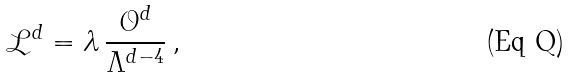Convert formula to latex. <formula><loc_0><loc_0><loc_500><loc_500>\mathcal { L } ^ { d } = \lambda \, \frac { \mathcal { O } ^ { d } } { \Lambda ^ { d - 4 } } \, ,</formula> 